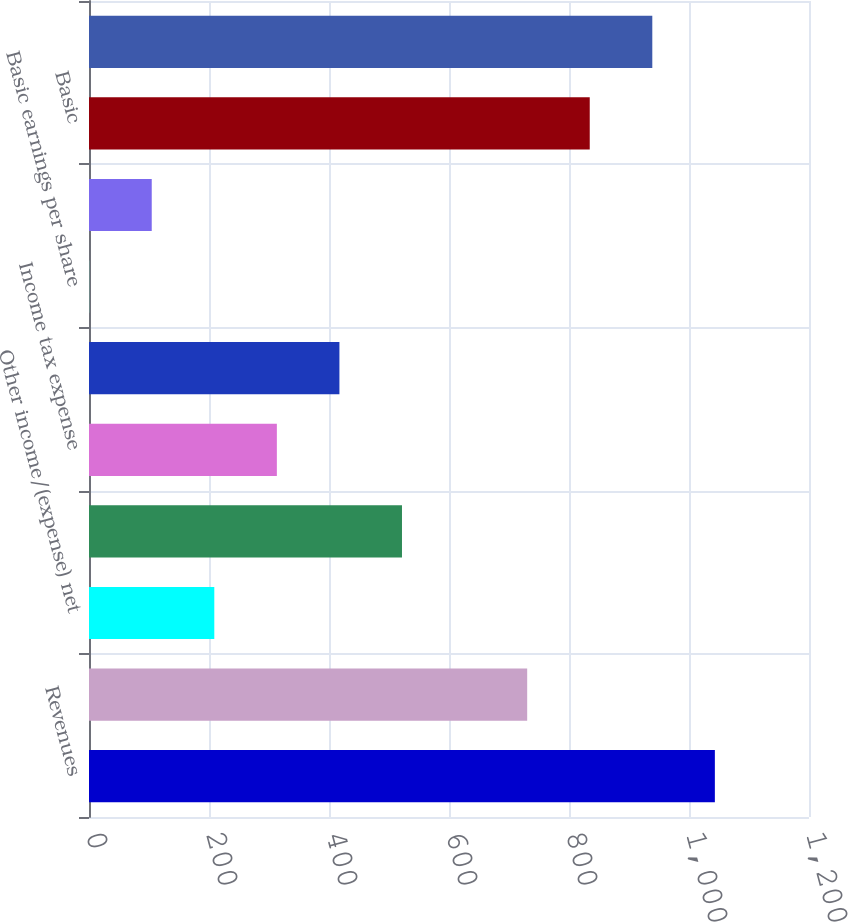Convert chart. <chart><loc_0><loc_0><loc_500><loc_500><bar_chart><fcel>Revenues<fcel>Expenses<fcel>Other income/(expense) net<fcel>Income before income taxes<fcel>Income tax expense<fcel>Net income<fcel>Basic earnings per share<fcel>Diluted earnings per share<fcel>Basic<fcel>Diluted<nl><fcel>1043.11<fcel>730.3<fcel>208.83<fcel>521.64<fcel>313.1<fcel>417.37<fcel>0.29<fcel>104.56<fcel>834.57<fcel>938.84<nl></chart> 